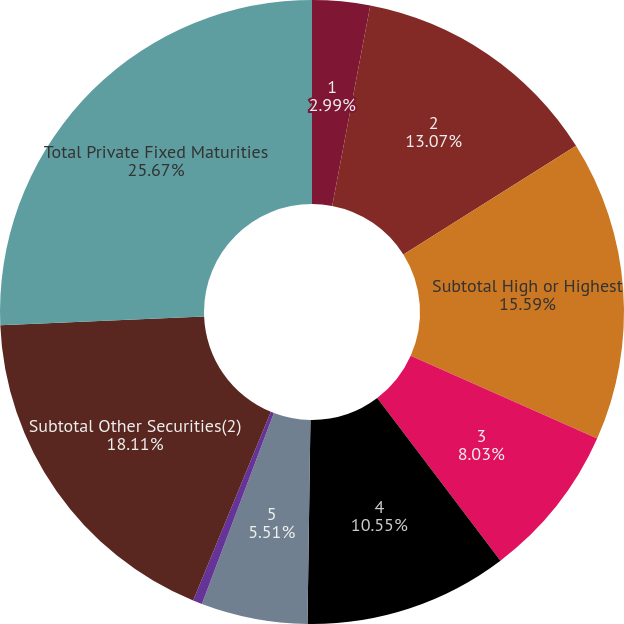<chart> <loc_0><loc_0><loc_500><loc_500><pie_chart><fcel>1<fcel>2<fcel>Subtotal High or Highest<fcel>3<fcel>4<fcel>5<fcel>6<fcel>Subtotal Other Securities(2)<fcel>Total Private Fixed Maturities<nl><fcel>2.99%<fcel>13.07%<fcel>15.59%<fcel>8.03%<fcel>10.55%<fcel>5.51%<fcel>0.48%<fcel>18.11%<fcel>25.67%<nl></chart> 